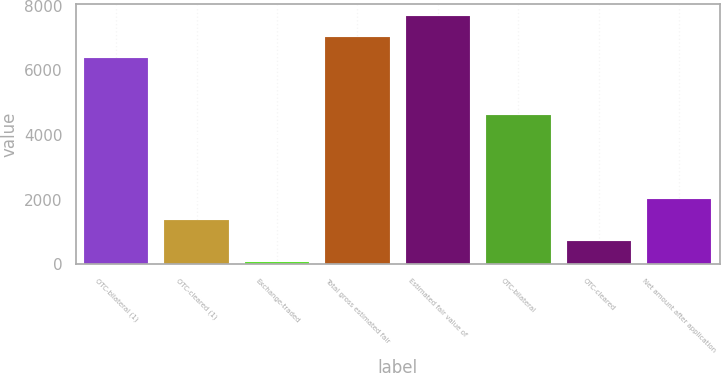Convert chart. <chart><loc_0><loc_0><loc_500><loc_500><bar_chart><fcel>OTC-bilateral (1)<fcel>OTC-cleared (1)<fcel>Exchange-traded<fcel>Total gross estimated fair<fcel>Estimated fair value of<fcel>OTC-bilateral<fcel>OTC-cleared<fcel>Net amount after application<nl><fcel>6367<fcel>1352.2<fcel>53<fcel>7016.6<fcel>7666.2<fcel>4631<fcel>702.6<fcel>2001.8<nl></chart> 